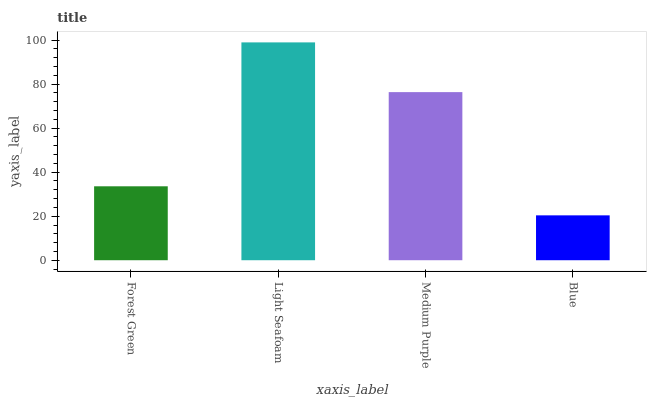Is Blue the minimum?
Answer yes or no. Yes. Is Light Seafoam the maximum?
Answer yes or no. Yes. Is Medium Purple the minimum?
Answer yes or no. No. Is Medium Purple the maximum?
Answer yes or no. No. Is Light Seafoam greater than Medium Purple?
Answer yes or no. Yes. Is Medium Purple less than Light Seafoam?
Answer yes or no. Yes. Is Medium Purple greater than Light Seafoam?
Answer yes or no. No. Is Light Seafoam less than Medium Purple?
Answer yes or no. No. Is Medium Purple the high median?
Answer yes or no. Yes. Is Forest Green the low median?
Answer yes or no. Yes. Is Blue the high median?
Answer yes or no. No. Is Light Seafoam the low median?
Answer yes or no. No. 